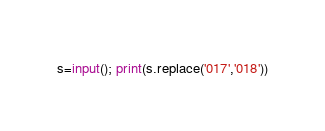<code> <loc_0><loc_0><loc_500><loc_500><_Python_>s=input(); print(s.replace('017','018'))</code> 